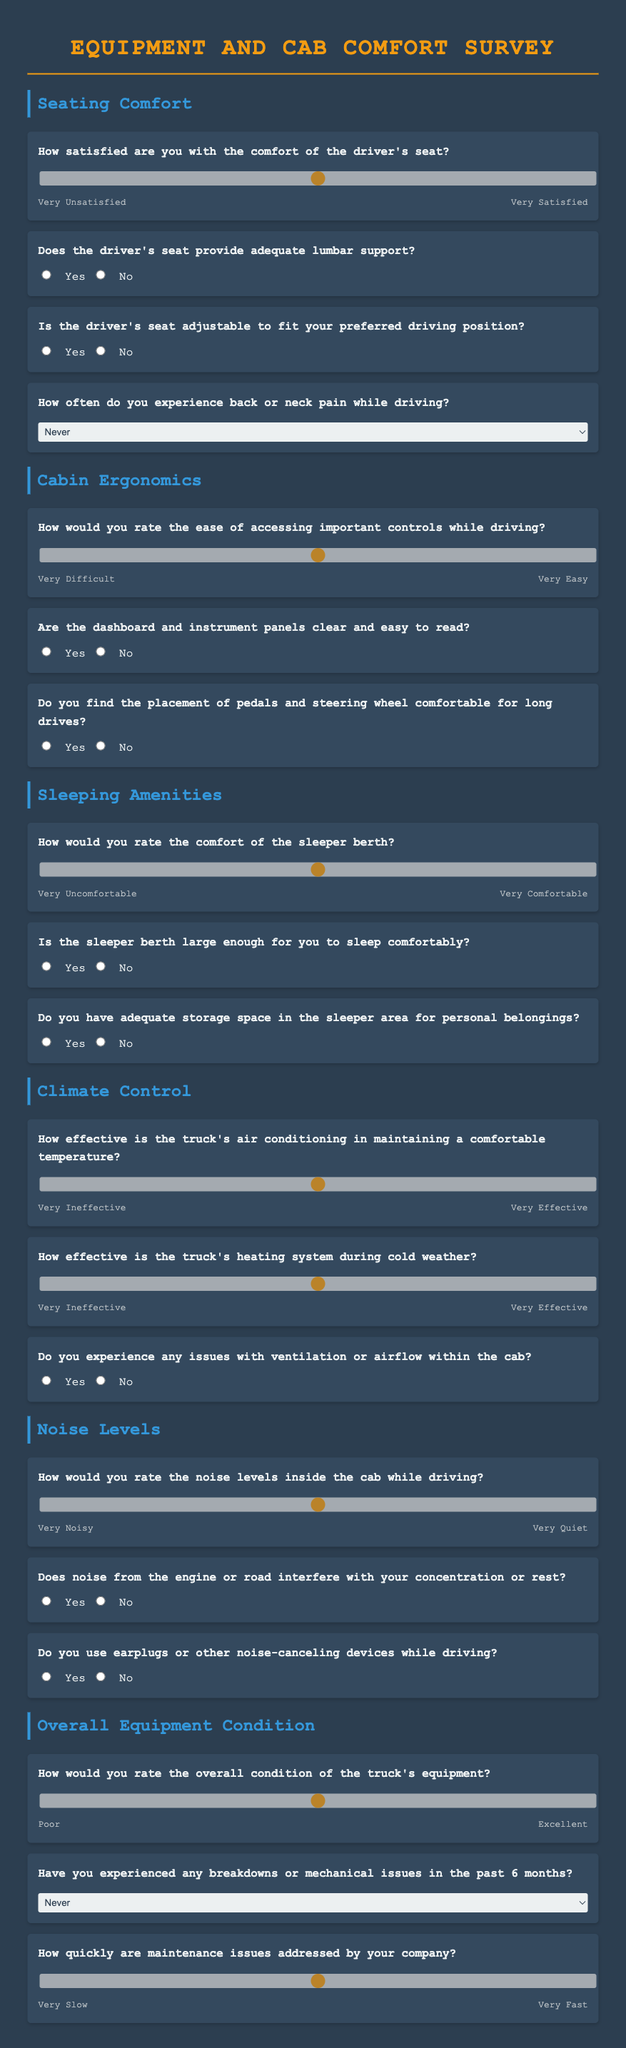What is the title of the survey? The title of the survey is displayed at the top of the document.
Answer: Equipment and Cab Comfort Survey How many main sections are included in the survey? The survey is divided into several main sections, each pertaining to a specific aspect of truck comfort and equipment.
Answer: Five What rating scale is used for the seating comfort question? The seating comfort question uses a range, allowing respondents to indicate their satisfaction level.
Answer: 1 to 5 What is the question about the effectiveness of the truck's air conditioning? This question asks for a specific rating related to climate control in the truck.
Answer: How effective is the truck's air conditioning in maintaining a comfortable temperature? Is there a question regarding the size of the sleeper berth? The survey includes a question specifically asking about the size of the sleeper berth.
Answer: Yes What does the question about noise from the engine or road inquire about? This question explores whether external noise affects the driver's experience.
Answer: Does noise from the engine or road interfere with your concentration or rest? How is the overall condition of the truck's equipment rated? The survey asks for a rating scale to evaluate the truck's overall equipment condition.
Answer: 1 to 5 Which section addresses the driver's seat's lumbar support? The section specifically asking about lumbar support is part of the seating comfort area.
Answer: Seating Comfort How often does the survey inquire about experiencing back or neck pain? The survey includes a frequency-based question regarding pain experienced while driving.
Answer: How often do you experience back or neck pain while driving? What response format is used for the number of breakdowns in the past 6 months? The survey uses a dropdown selection format for responses regarding breakdown frequencies.
Answer: Dropdown selection 